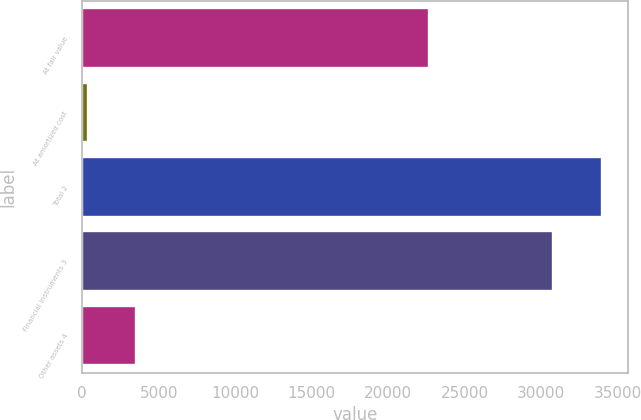Convert chart to OTSL. <chart><loc_0><loc_0><loc_500><loc_500><bar_chart><fcel>At fair value<fcel>At amortized cost<fcel>Total 2<fcel>Financial instruments 3<fcel>Other assets 4<nl><fcel>22685<fcel>360<fcel>33930<fcel>30765<fcel>3525<nl></chart> 